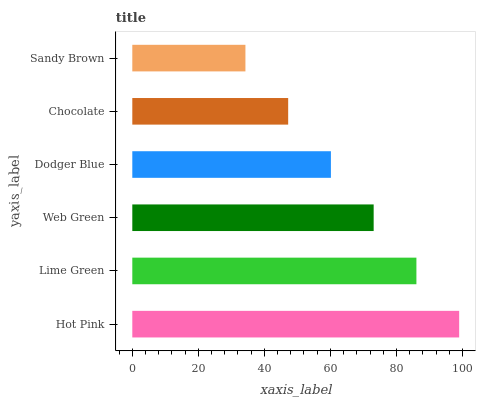Is Sandy Brown the minimum?
Answer yes or no. Yes. Is Hot Pink the maximum?
Answer yes or no. Yes. Is Lime Green the minimum?
Answer yes or no. No. Is Lime Green the maximum?
Answer yes or no. No. Is Hot Pink greater than Lime Green?
Answer yes or no. Yes. Is Lime Green less than Hot Pink?
Answer yes or no. Yes. Is Lime Green greater than Hot Pink?
Answer yes or no. No. Is Hot Pink less than Lime Green?
Answer yes or no. No. Is Web Green the high median?
Answer yes or no. Yes. Is Dodger Blue the low median?
Answer yes or no. Yes. Is Lime Green the high median?
Answer yes or no. No. Is Sandy Brown the low median?
Answer yes or no. No. 